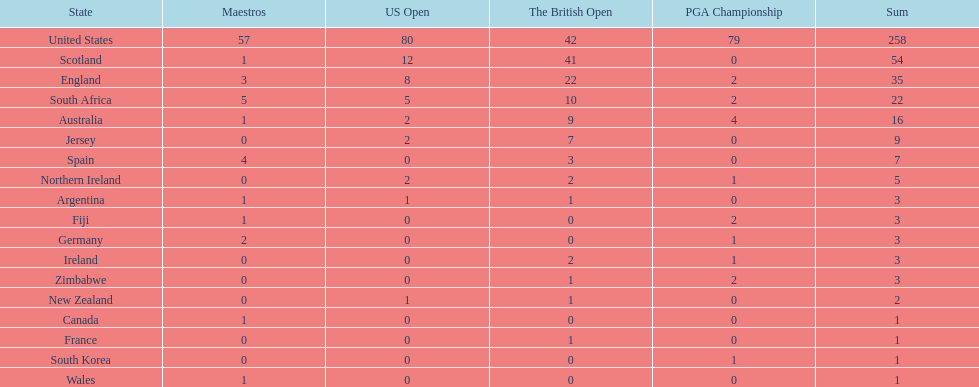How many u.s. open wins does fiji have? 0. 